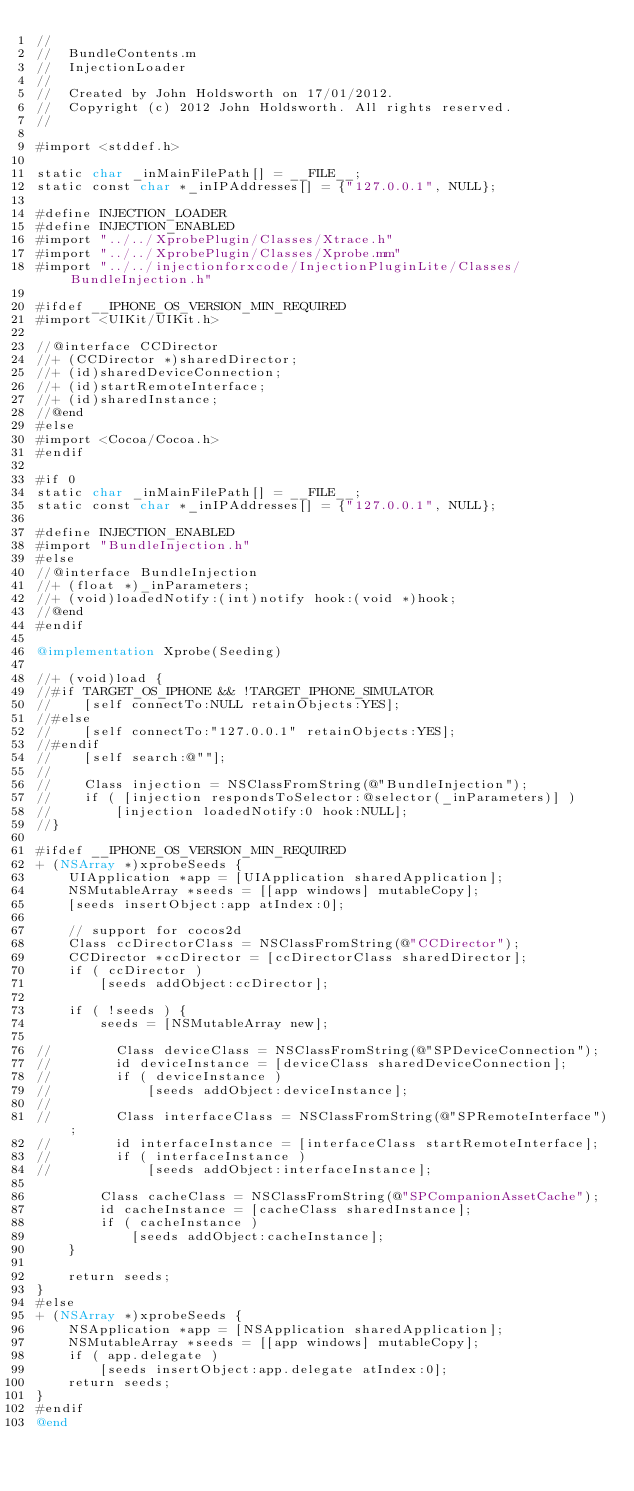<code> <loc_0><loc_0><loc_500><loc_500><_ObjectiveC_>//
//  BundleContents.m
//  InjectionLoader
//
//  Created by John Holdsworth on 17/01/2012.
//  Copyright (c) 2012 John Holdsworth. All rights reserved.
//

#import <stddef.h>

static char _inMainFilePath[] = __FILE__;
static const char *_inIPAddresses[] = {"127.0.0.1", NULL};

#define INJECTION_LOADER
#define INJECTION_ENABLED
#import "../../XprobePlugin/Classes/Xtrace.h"
#import "../../XprobePlugin/Classes/Xprobe.mm"
#import "../../injectionforxcode/InjectionPluginLite/Classes/BundleInjection.h"

#ifdef __IPHONE_OS_VERSION_MIN_REQUIRED
#import <UIKit/UIKit.h>

//@interface CCDirector
//+ (CCDirector *)sharedDirector;
//+ (id)sharedDeviceConnection;
//+ (id)startRemoteInterface;
//+ (id)sharedInstance;
//@end
#else
#import <Cocoa/Cocoa.h>
#endif

#if 0
static char _inMainFilePath[] = __FILE__;
static const char *_inIPAddresses[] = {"127.0.0.1", NULL};

#define INJECTION_ENABLED
#import "BundleInjection.h"
#else
//@interface BundleInjection
//+ (float *)_inParameters;
//+ (void)loadedNotify:(int)notify hook:(void *)hook;
//@end
#endif

@implementation Xprobe(Seeding)

//+ (void)load {
//#if TARGET_OS_IPHONE && !TARGET_IPHONE_SIMULATOR
//    [self connectTo:NULL retainObjects:YES];
//#else
//    [self connectTo:"127.0.0.1" retainObjects:YES];
//#endif
//    [self search:@""];
//
//    Class injection = NSClassFromString(@"BundleInjection");
//    if ( [injection respondsToSelector:@selector(_inParameters)] )
//        [injection loadedNotify:0 hook:NULL];
//}

#ifdef __IPHONE_OS_VERSION_MIN_REQUIRED
+ (NSArray *)xprobeSeeds {
    UIApplication *app = [UIApplication sharedApplication];
    NSMutableArray *seeds = [[app windows] mutableCopy];
    [seeds insertObject:app atIndex:0];

    // support for cocos2d
    Class ccDirectorClass = NSClassFromString(@"CCDirector");
    CCDirector *ccDirector = [ccDirectorClass sharedDirector];
    if ( ccDirector )
        [seeds addObject:ccDirector];

    if ( !seeds ) {
        seeds = [NSMutableArray new];

//        Class deviceClass = NSClassFromString(@"SPDeviceConnection");
//        id deviceInstance = [deviceClass sharedDeviceConnection];
//        if ( deviceInstance )
//            [seeds addObject:deviceInstance];
//
//        Class interfaceClass = NSClassFromString(@"SPRemoteInterface");
//        id interfaceInstance = [interfaceClass startRemoteInterface];
//        if ( interfaceInstance )
//            [seeds addObject:interfaceInstance];

        Class cacheClass = NSClassFromString(@"SPCompanionAssetCache");
        id cacheInstance = [cacheClass sharedInstance];
        if ( cacheInstance )
            [seeds addObject:cacheInstance];
    }

    return seeds;
}
#else
+ (NSArray *)xprobeSeeds {
    NSApplication *app = [NSApplication sharedApplication];
    NSMutableArray *seeds = [[app windows] mutableCopy];
    if ( app.delegate )
        [seeds insertObject:app.delegate atIndex:0];
    return seeds;
}
#endif
@end
</code> 